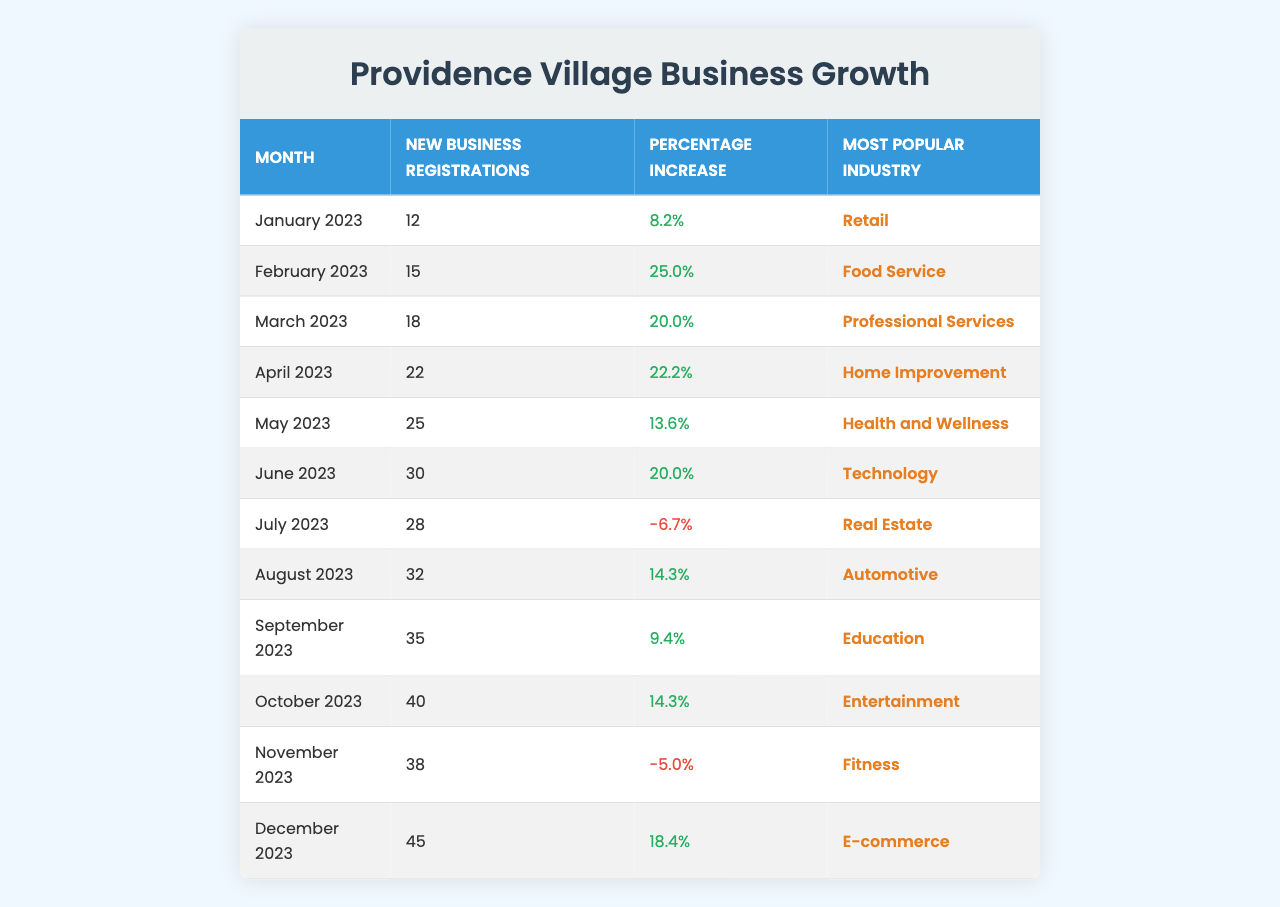What was the month with the highest number of new business registrations? Looking at the "New Business Registrations" column, December 2023 has the highest count with 45 registrations.
Answer: December 2023 Which month had a decrease in new business registrations? The table shows that July 2023 and November 2023 both had a decrease in registrations, marked by negative percentages in the "Percentage Increase" column.
Answer: July 2023 and November 2023 What is the percentage increase of new business registrations from January 2023 to February 2023? The registrations increased from 12 in January to 15 in February. The percentage increase is calculated as ((15 - 12) / 12) * 100 = 25.0%.
Answer: 25.0% How many new business registrations were there in June 2023? Referring to the "New Business Registrations" column, June 2023 has 30 new registrations.
Answer: 30 What is the most popular industry for new business registrations in October 2023? The "Most Popular Industry" column indicates that the most popular industry in October 2023 was Entertainment.
Answer: Entertainment What was the overall increase in new business registrations from January 2023 to December 2023? The registrations increased from 12 in January to 45 in December. The overall increase is 45 - 12 = 33 registrations.
Answer: 33 Which month had the highest percentage increase in new business registrations? By checking the "Percentage Increase" column, February 2023 had the highest percentage increase with 25.0%.
Answer: February 2023 In which month did Health and Wellness become the most popular industry? The "Most Popular Industry" column shows that Health and Wellness was the leading industry in May 2023.
Answer: May 2023 What is the average new business registrations for the months depicted in the table? Adding the registrations from all months gives 12 + 15 + 18 + 22 + 25 + 30 + 28 + 32 + 35 + 40 + 38 + 45 =  388. Dividing by 12 months, the average is 388 / 12 = 32.33.
Answer: 32.33 Is there a month where the number of new registrations decreased compared to the previous month? Yes, both July 2023 and November 2023 showed decreases in registrations relative to the prior months.
Answer: Yes 